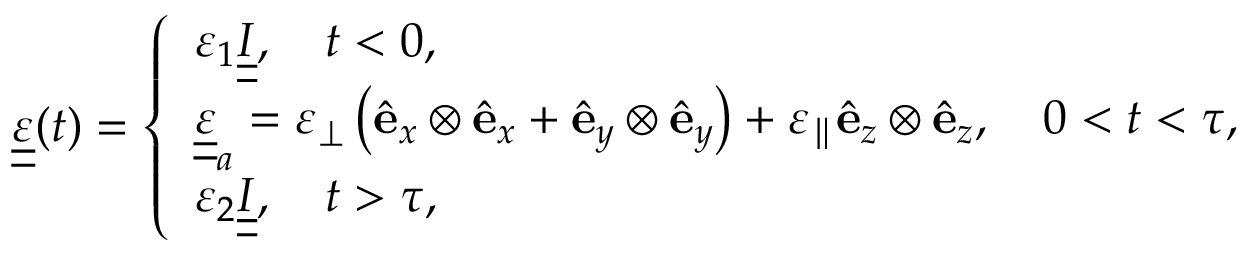Convert formula to latex. <formula><loc_0><loc_0><loc_500><loc_500>\begin{array} { r } { \underline { { \underline { \varepsilon } } } ( t ) = \left \{ \begin{array} { l l } { \varepsilon _ { 1 } \underline { { \underline { I } } } , \quad t < 0 , } \\ { \underline { { \underline { \varepsilon } } } _ { a } = \varepsilon _ { \perp } \left ( { \hat { e } } _ { x } \otimes { \hat { e } } _ { x } + { \hat { e } } _ { y } \otimes { \hat { e } } _ { y } \right ) + \varepsilon _ { \| } { \hat { e } } _ { z } \otimes { \hat { e } } _ { z } , \quad 0 < t < \tau , } \\ { \varepsilon _ { 2 } \underline { { \underline { I } } } , \quad t > \tau , } \end{array} } \end{array}</formula> 